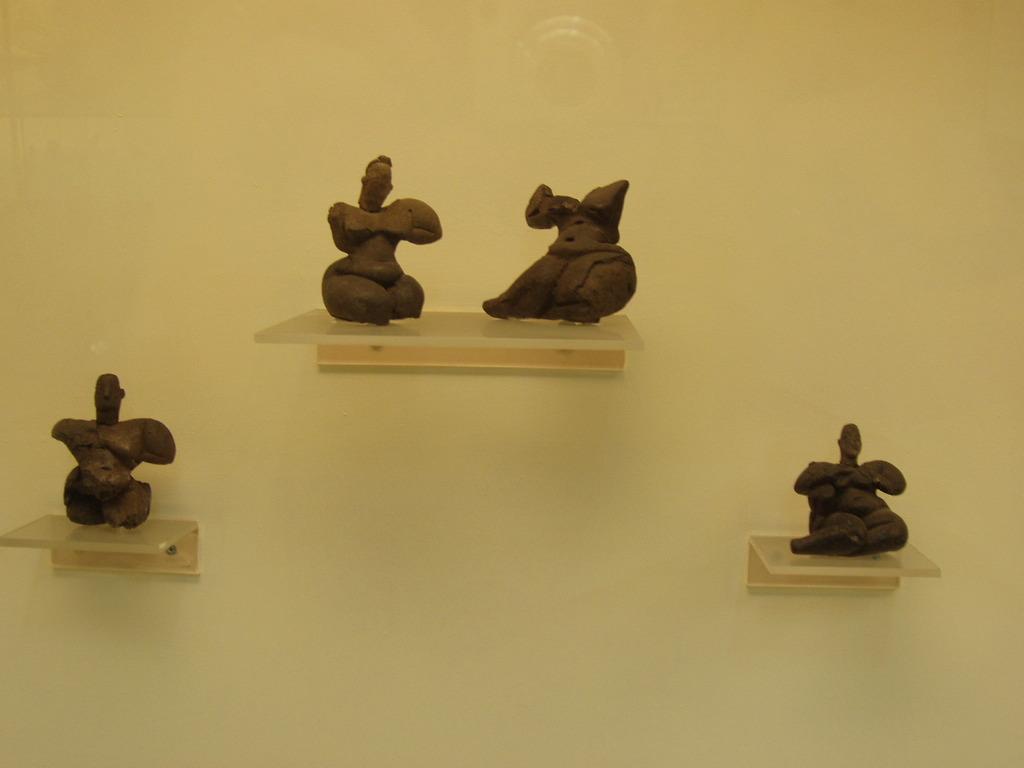Can you describe this image briefly? In this image I can see a cream colored wall to which I can see few desks and on the desks I can see few sculptures which are brown in color. 